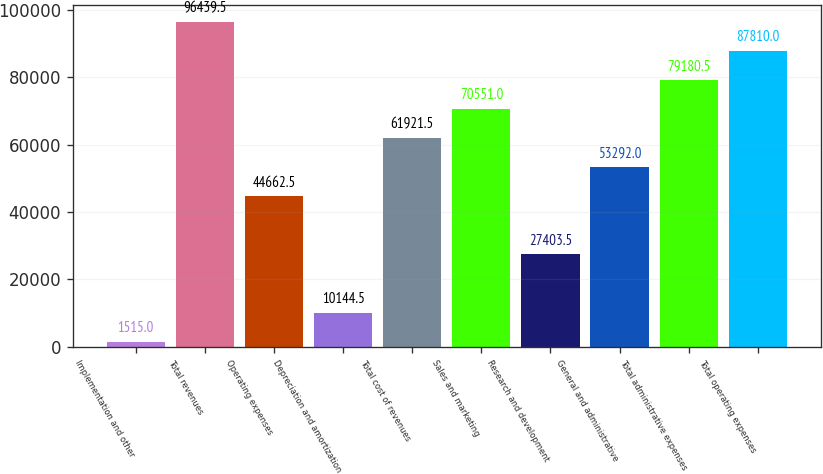<chart> <loc_0><loc_0><loc_500><loc_500><bar_chart><fcel>Implementation and other<fcel>Total revenues<fcel>Operating expenses<fcel>Depreciation and amortization<fcel>Total cost of revenues<fcel>Sales and marketing<fcel>Research and development<fcel>General and administrative<fcel>Total administrative expenses<fcel>Total operating expenses<nl><fcel>1515<fcel>96439.5<fcel>44662.5<fcel>10144.5<fcel>61921.5<fcel>70551<fcel>27403.5<fcel>53292<fcel>79180.5<fcel>87810<nl></chart> 